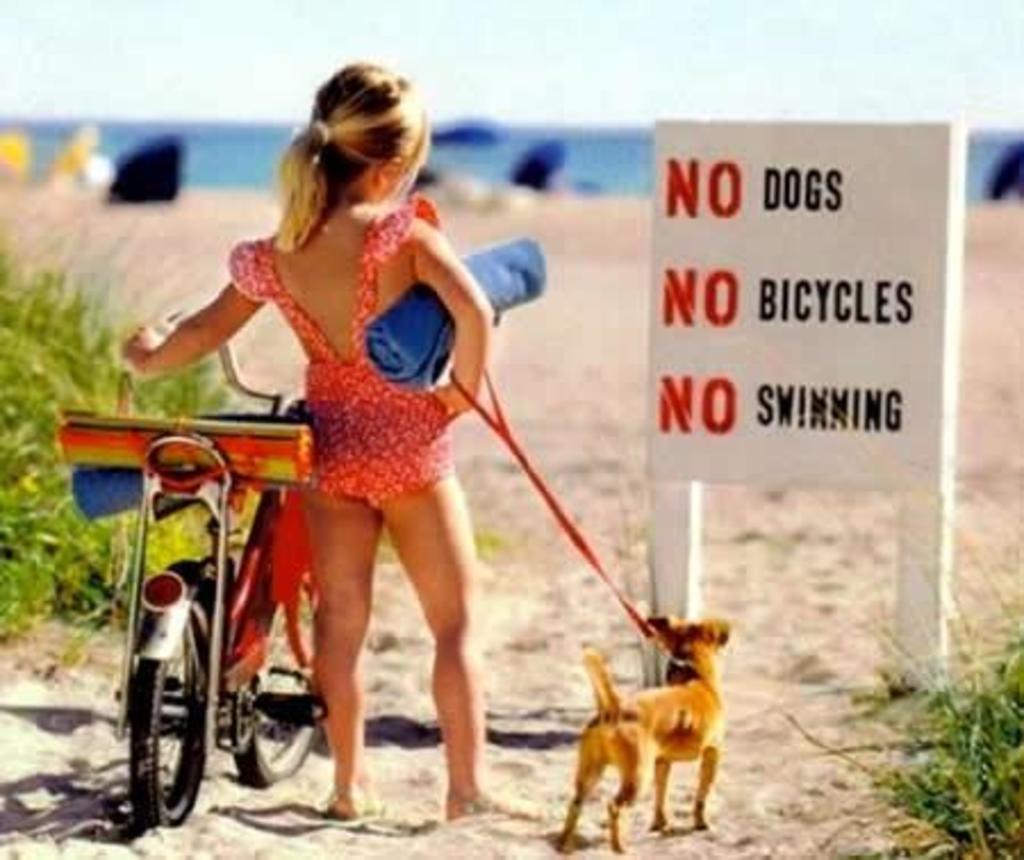Describe this image in one or two sentences. In this image there is a girl standing by holding a bike to her left, and there is a dog on her right, in front of the girl there is a board with some text written on it, behind the board there is sand in front of the sand there is water. 